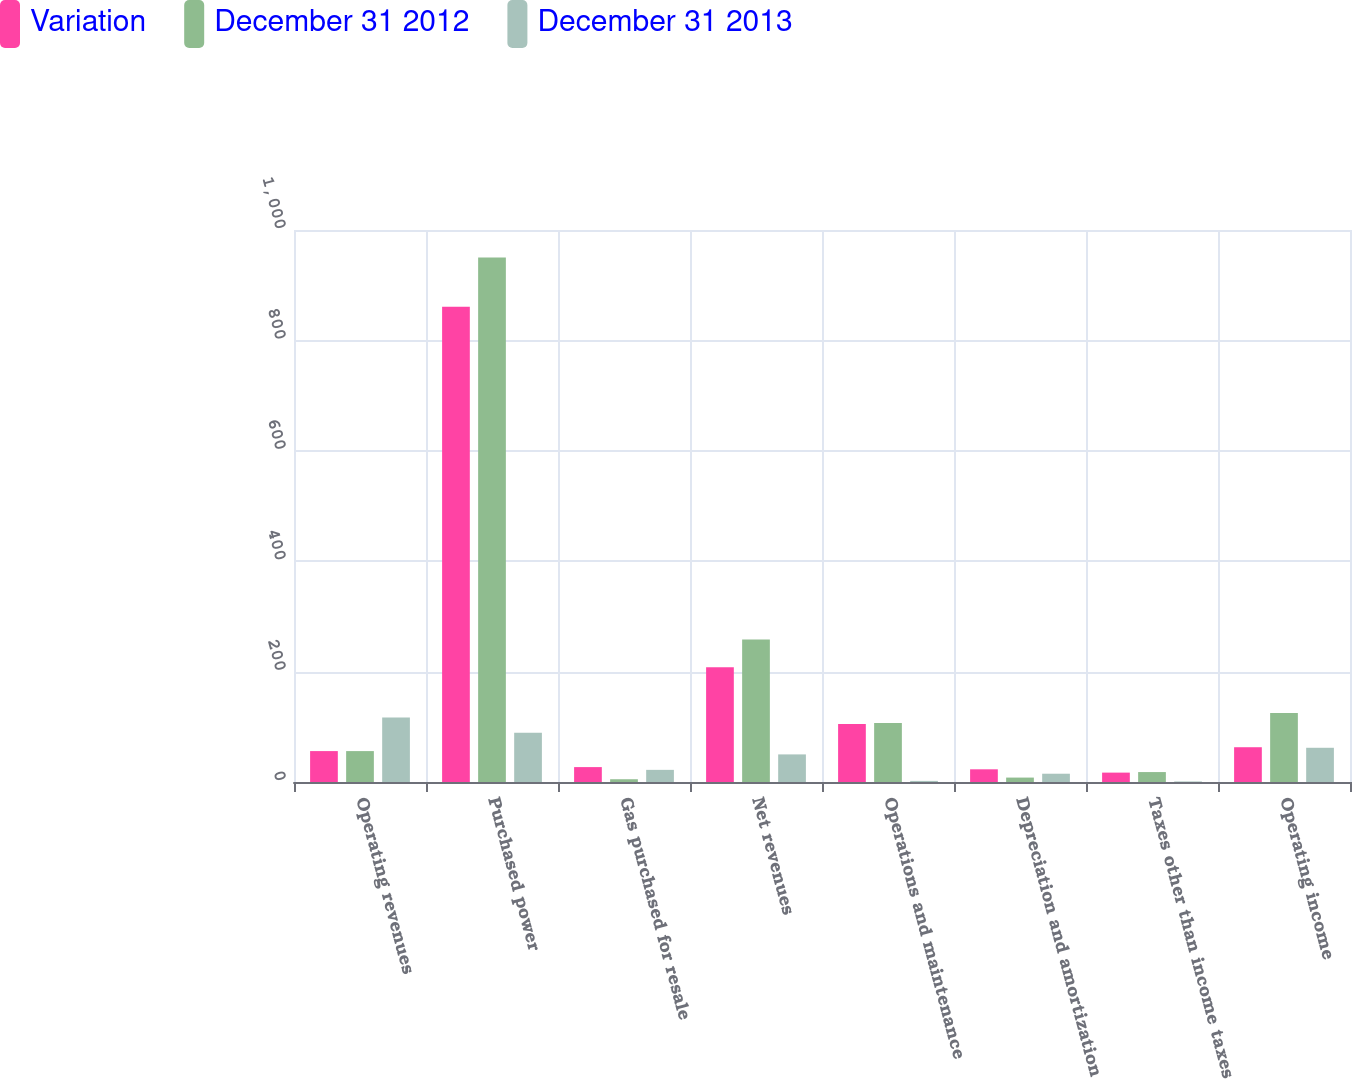Convert chart to OTSL. <chart><loc_0><loc_0><loc_500><loc_500><stacked_bar_chart><ecel><fcel>Operating revenues<fcel>Purchased power<fcel>Gas purchased for resale<fcel>Net revenues<fcel>Operations and maintenance<fcel>Depreciation and amortization<fcel>Taxes other than income taxes<fcel>Operating income<nl><fcel>Variation<fcel>56<fcel>861<fcel>27<fcel>208<fcel>105<fcel>23<fcel>17<fcel>63<nl><fcel>December 31 2012<fcel>56<fcel>950<fcel>5<fcel>258<fcel>107<fcel>8<fcel>18<fcel>125<nl><fcel>December 31 2013<fcel>117<fcel>89<fcel>22<fcel>50<fcel>2<fcel>15<fcel>1<fcel>62<nl></chart> 